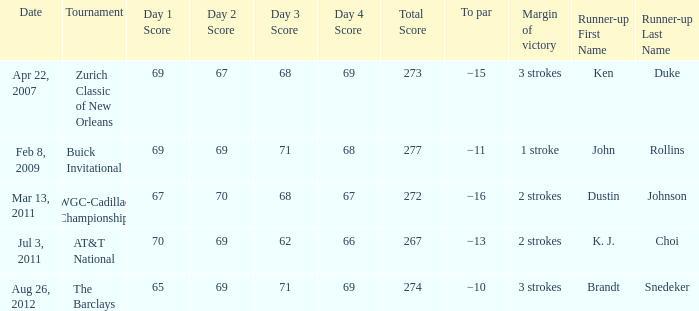What is the date that has a winning score of 67-70-68-67=272? Mar 13, 2011. 